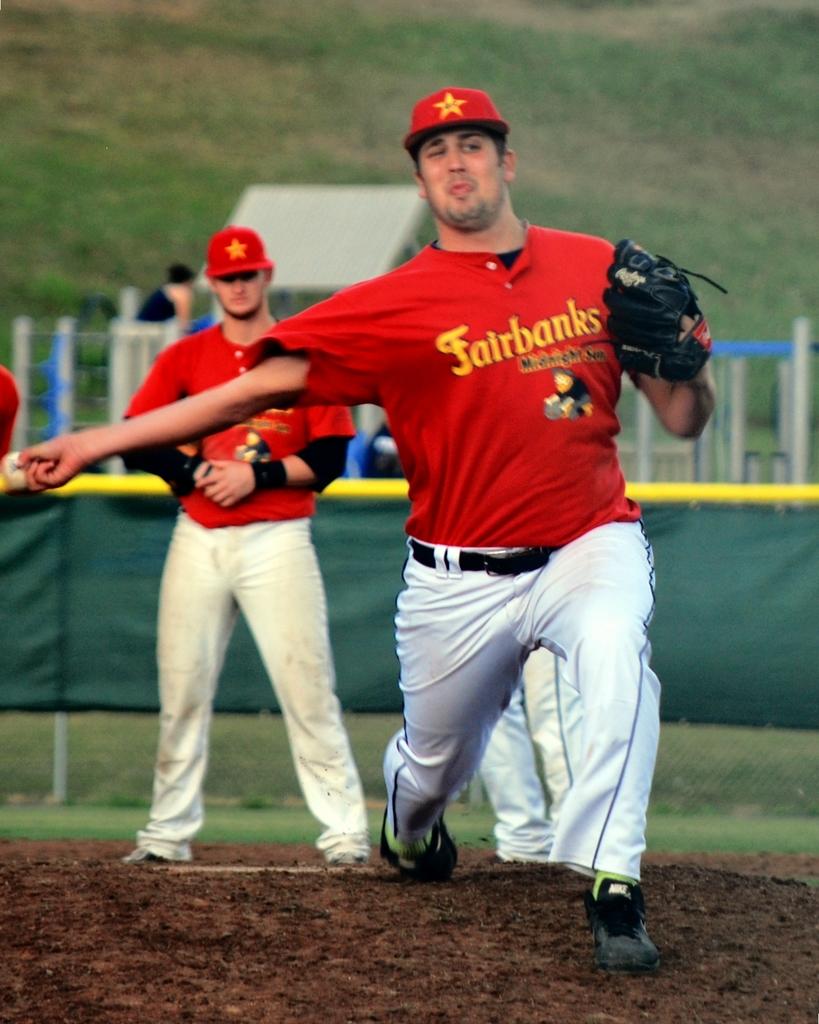What is the team name on the jersey?
Offer a terse response. Fairbanks. Written on the hats is obama?
Provide a short and direct response. No. 